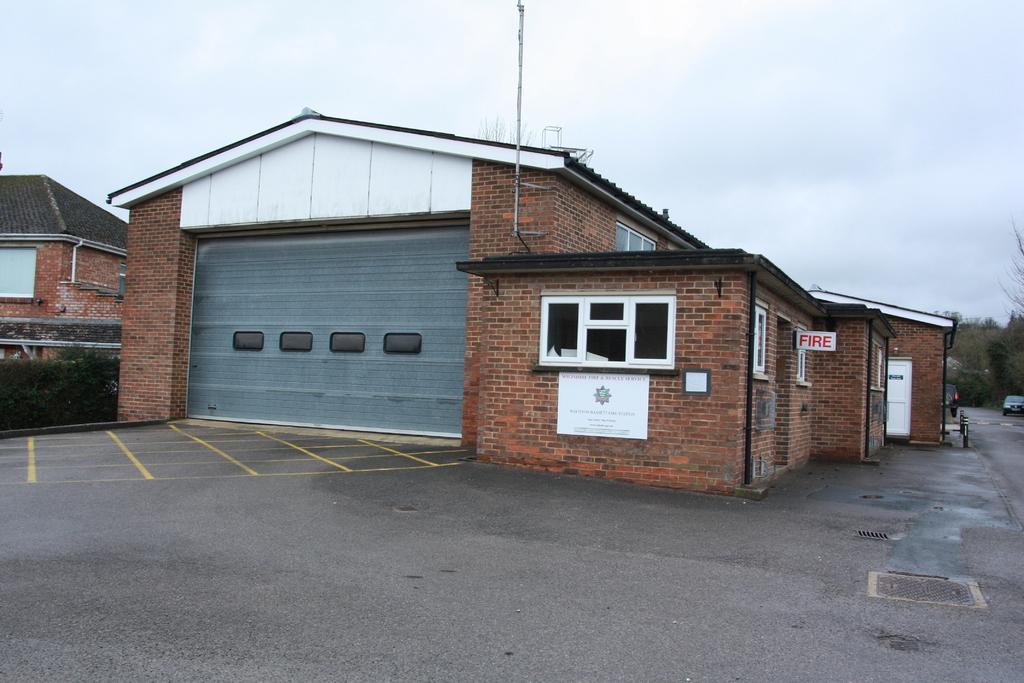Describe this image in one or two sentences. On the left I can see some plants near to the shelter. On the right I can see the door, poles, sign boards and window. In front of the door there is a bicycle which is parked on the road. In the background I can see the car, road and many trees. At the top I can see the sky and clouds. 